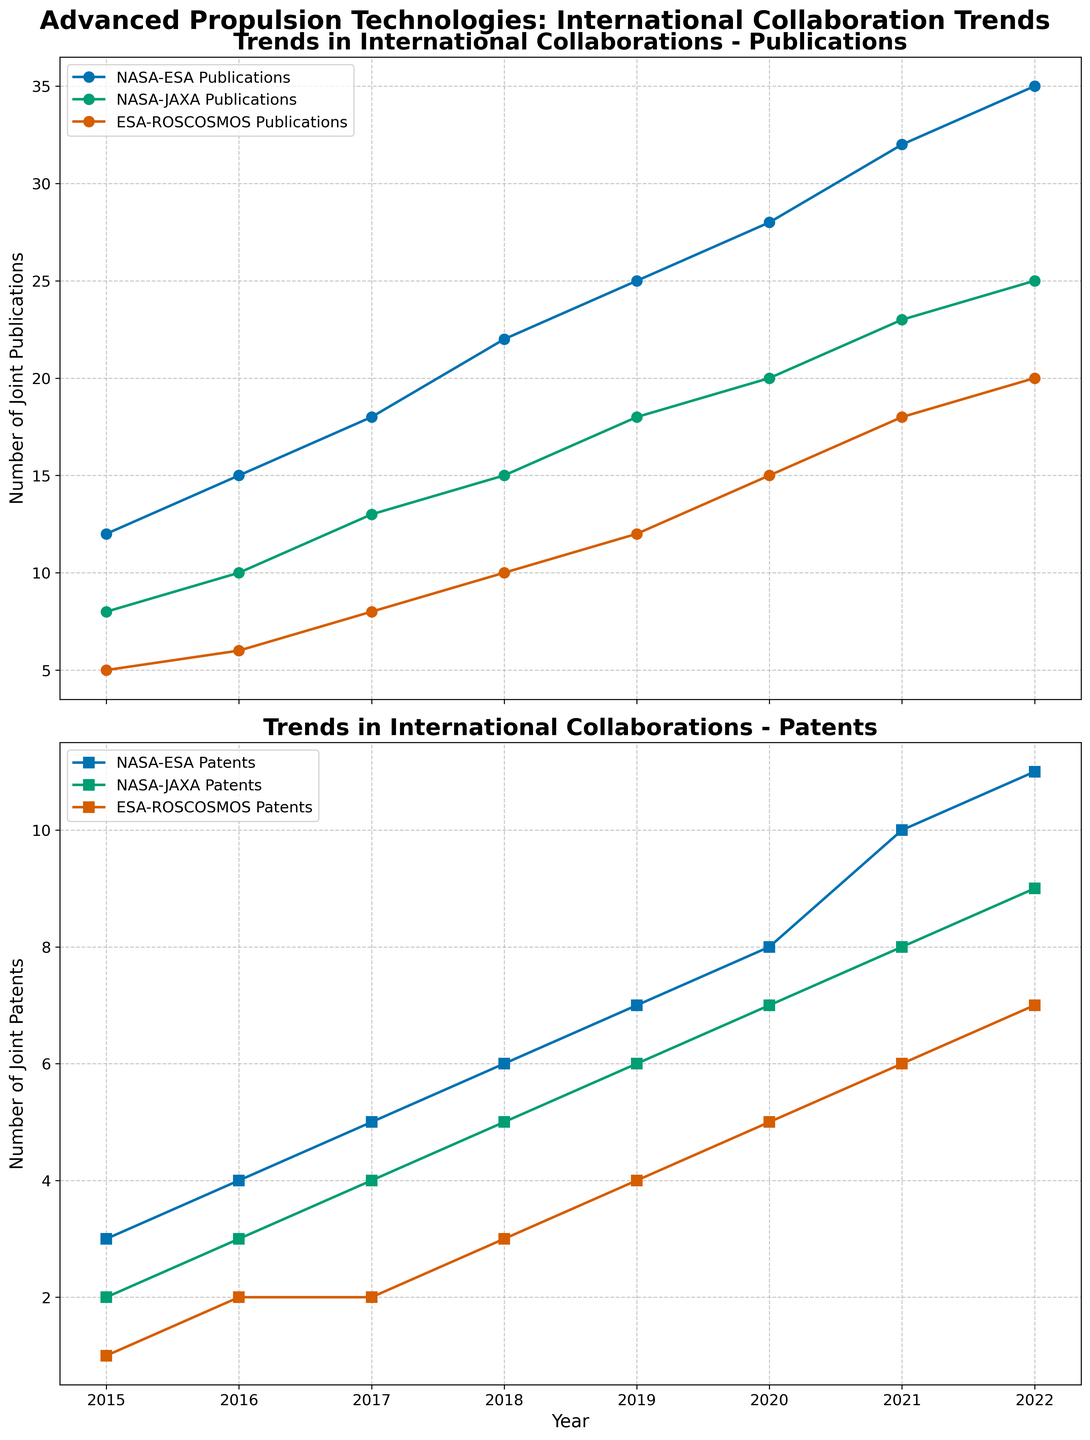what is the title of the upper subplot? The title can be directly observed at the top of the upper subplot in the figure.
Answer: Trends in International Collaborations - Publications what is the total number of joint NASA-ESA publications from 2015 to 2022? Sum the numbers of NASA-ESA publications for each year from 2015 to 2022: 12 + 15 + 18 + 22 + 25 + 28 + 32 + 35 = 187.
Answer: 187 How many more NASA-JAXA publications were there in 2022 compared to 2015? Find the difference between the NASA-JAXA publication numbers in 2022 (25) and 2015 (8): 25 - 8 = 17.
Answer: 17 Which collaboration has the least number of joint patents in 2015? Compare the number of joint patents for NASA-ESA (3), NASA-JAXA (2), and ESA-ROSCOSMOS (1) in 2015. The least is ESA-ROSCOSMOS with 1.
Answer: ESA-ROSCOSMOS Which year did NASA-JAXA collaborations start publishing more than 15 papers annually? Identify the year in which the number of NASA-JAXA publications first exceeds 15. The value exceeded 15 in 2020, with 20 publications.
Answer: 2020 Are the trends in joint patents for NASA-ESA and NASA-JAXA collaborations increasing at the same rate? To compare the trends, observe the slope of the lines. NASA-ESA patents increase from 3 to 11 over 8 years (8 patents total, 1 per year), whereas NASA-JAXA patents increase from 2 to 9 over 8 years (7 patents total, slightly less than 1 per year). The rate of increase is slightly higher for NASA-ESA.
Answer: No Which collaboration had the highest increase in the number of joint publications from 2015 to 2022? Calculate the increase for each collaboration: NASA-ESA (35-12=23), NASA-JAXA (25-8=17), ESA-ROSCOSMOS (20-5=15). NASA-ESA had the highest increase with 23 publications.
Answer: NASA-ESA What is the average number of ESA-ROSCOSMOS joint patents per year between 2015 and 2022? Sum the numbers of ESA-ROSCOSMOS patents for each year and then divide by 8 (the number of years): (1+2+2+3+4+5+6+7) / 8 = 30 / 8 = 3.75
Answer: 3.75 In which year did all three types of collaborations reach at least 10 joint publications? Identify the year when NASA-ESA, NASA-JAXA, and ESA-ROSCOSMOS collaborations all have at least 10 publications. In 2018: NASA-ESA (22), NASA-JAXA (15), ESA-ROSCOSMOS (10).
Answer: 2018 